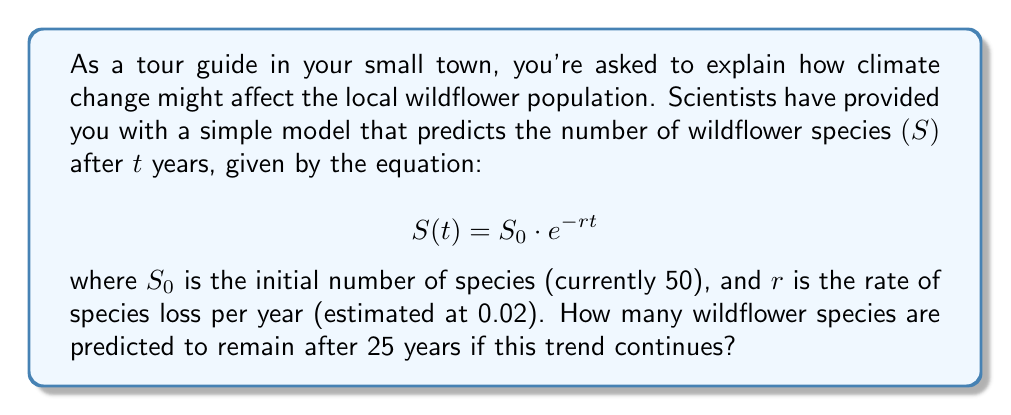Help me with this question. Let's break this down step-by-step:

1) We're given the equation: $S(t) = S_0 \cdot e^{-rt}$

2) We know the following values:
   - $S_0 = 50$ (initial number of species)
   - $r = 0.02$ (rate of species loss per year)
   - $t = 25$ (number of years in the future)

3) Let's substitute these values into the equation:

   $S(25) = 50 \cdot e^{-0.02 \cdot 25}$

4) First, let's calculate the exponent:
   $-0.02 \cdot 25 = -0.5$

5) Now our equation looks like this:
   $S(25) = 50 \cdot e^{-0.5}$

6) Using a calculator or computer, we can calculate $e^{-0.5}$:
   $e^{-0.5} \approx 0.6065$

7) Finally, we multiply:
   $S(25) = 50 \cdot 0.6065 \approx 30.325$

8) Since we're dealing with whole species, we round down to the nearest integer.
Answer: 30 wildflower species 